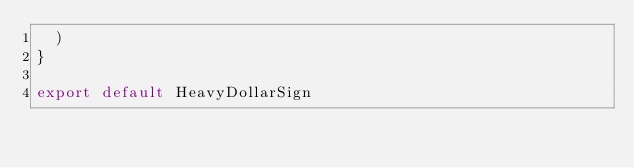Convert code to text. <code><loc_0><loc_0><loc_500><loc_500><_TypeScript_>  )
}

export default HeavyDollarSign
</code> 